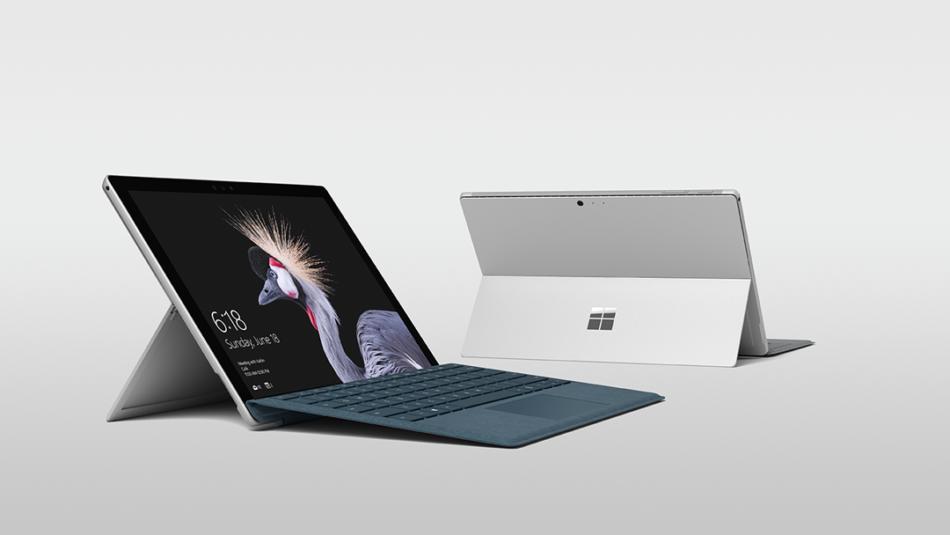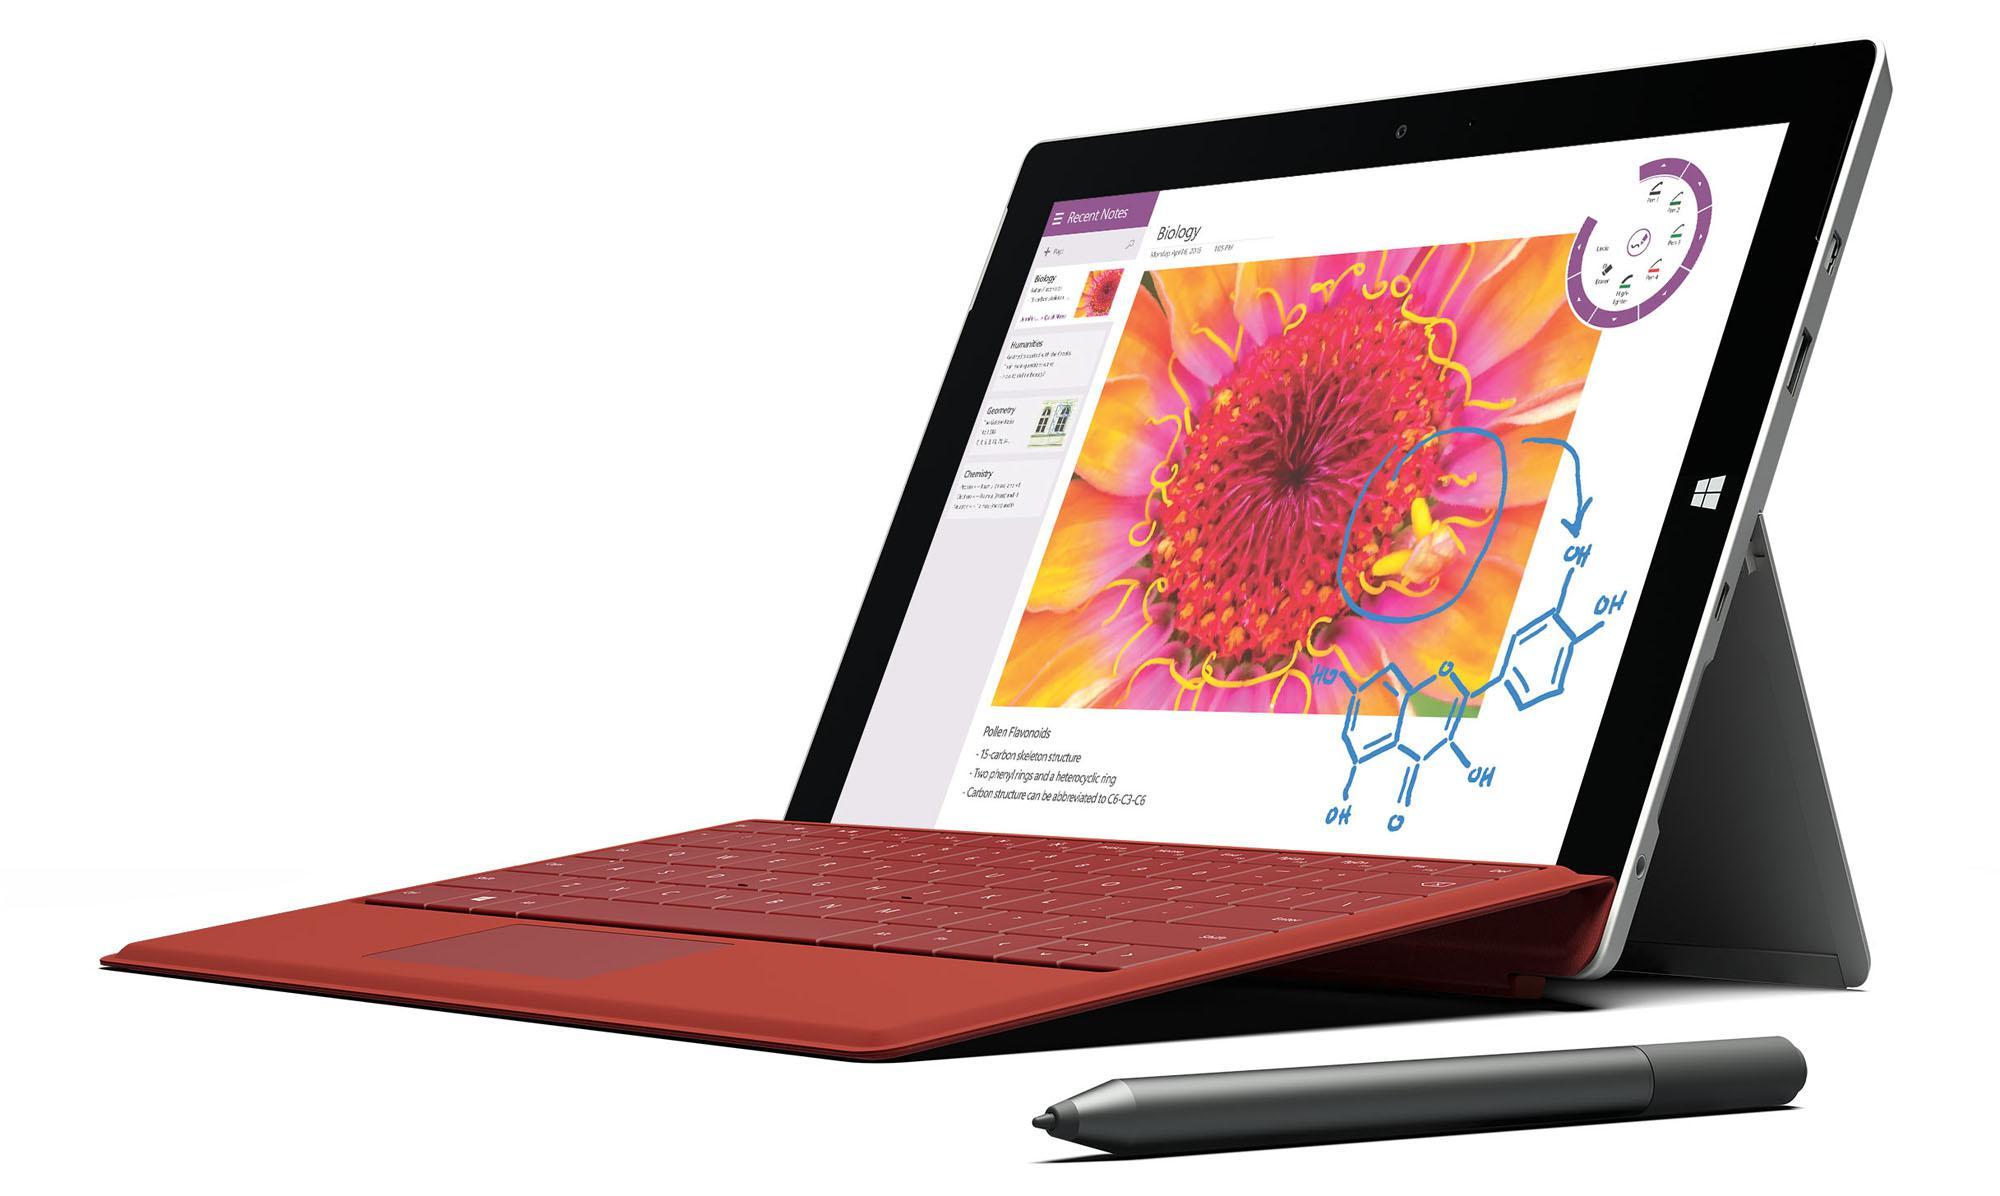The first image is the image on the left, the second image is the image on the right. Assess this claim about the two images: "There is a single laptop with a stylus pen next to it in one of the images.". Correct or not? Answer yes or no. Yes. The first image is the image on the left, the second image is the image on the right. Given the left and right images, does the statement "Each image includes exactly one visible screen, and the screens in the left and right images face toward each other." hold true? Answer yes or no. Yes. 